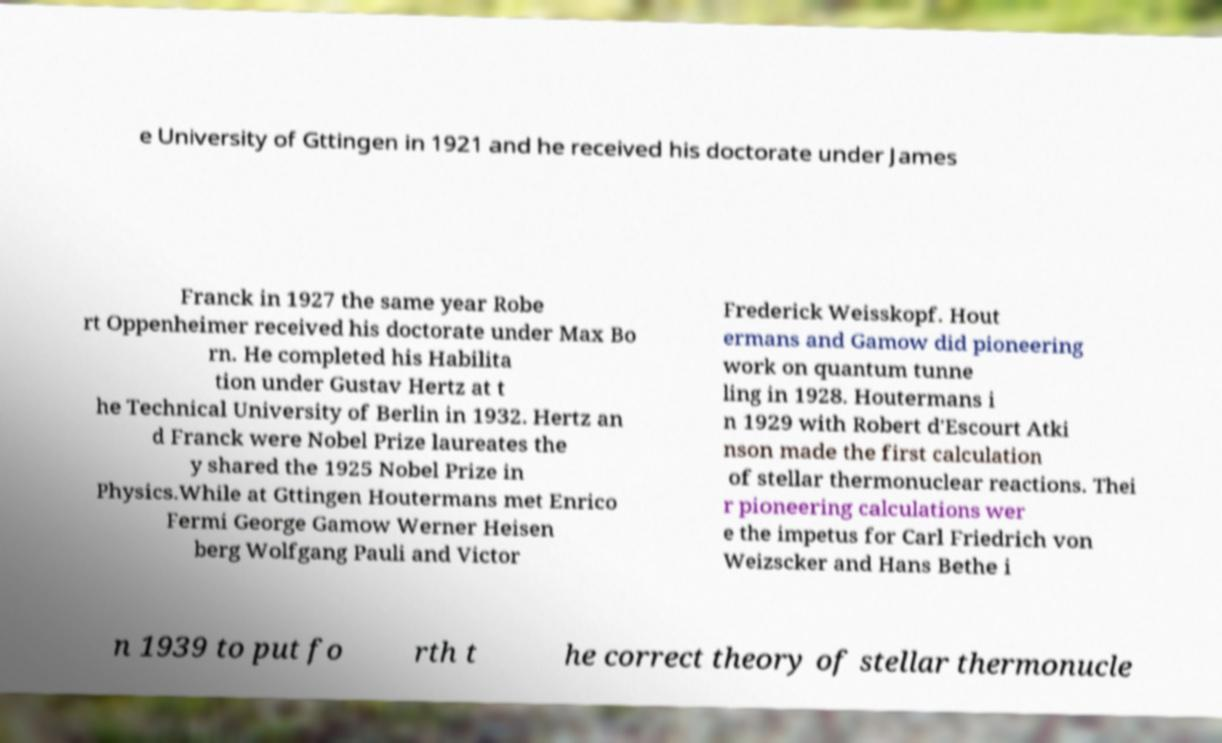Please read and relay the text visible in this image. What does it say? e University of Gttingen in 1921 and he received his doctorate under James Franck in 1927 the same year Robe rt Oppenheimer received his doctorate under Max Bo rn. He completed his Habilita tion under Gustav Hertz at t he Technical University of Berlin in 1932. Hertz an d Franck were Nobel Prize laureates the y shared the 1925 Nobel Prize in Physics.While at Gttingen Houtermans met Enrico Fermi George Gamow Werner Heisen berg Wolfgang Pauli and Victor Frederick Weisskopf. Hout ermans and Gamow did pioneering work on quantum tunne ling in 1928. Houtermans i n 1929 with Robert d'Escourt Atki nson made the first calculation of stellar thermonuclear reactions. Thei r pioneering calculations wer e the impetus for Carl Friedrich von Weizscker and Hans Bethe i n 1939 to put fo rth t he correct theory of stellar thermonucle 